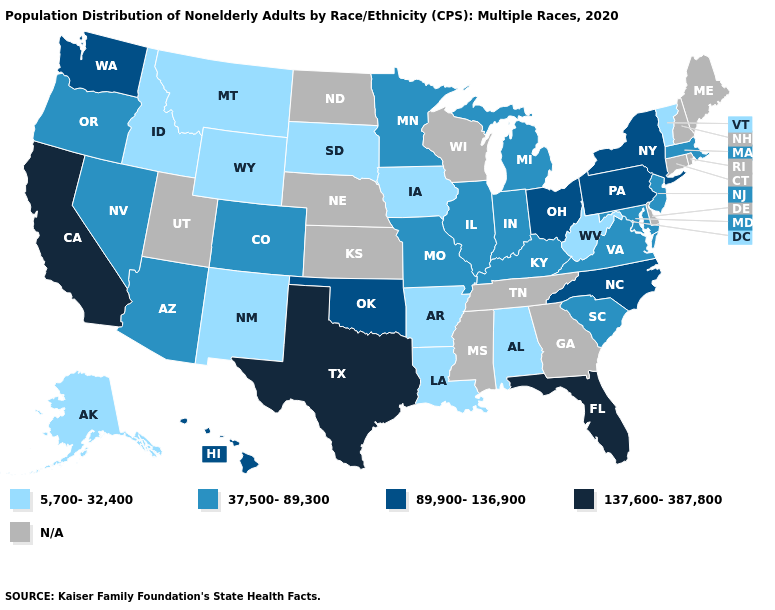Name the states that have a value in the range 89,900-136,900?
Concise answer only. Hawaii, New York, North Carolina, Ohio, Oklahoma, Pennsylvania, Washington. What is the value of Hawaii?
Concise answer only. 89,900-136,900. What is the value of Nevada?
Be succinct. 37,500-89,300. What is the value of Virginia?
Write a very short answer. 37,500-89,300. What is the value of Nevada?
Quick response, please. 37,500-89,300. Does Florida have the highest value in the USA?
Short answer required. Yes. Does the first symbol in the legend represent the smallest category?
Answer briefly. Yes. Does Maryland have the lowest value in the USA?
Keep it brief. No. What is the highest value in the West ?
Write a very short answer. 137,600-387,800. What is the lowest value in the Northeast?
Answer briefly. 5,700-32,400. Among the states that border Illinois , which have the highest value?
Concise answer only. Indiana, Kentucky, Missouri. What is the lowest value in the USA?
Answer briefly. 5,700-32,400. Does Texas have the highest value in the USA?
Short answer required. Yes. Which states have the lowest value in the West?
Keep it brief. Alaska, Idaho, Montana, New Mexico, Wyoming. 